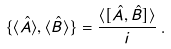<formula> <loc_0><loc_0><loc_500><loc_500>\{ \langle \hat { A } \rangle , \langle \hat { B } \rangle \} = \frac { \langle [ \hat { A } , \hat { B } ] \rangle } { i } \, .</formula> 